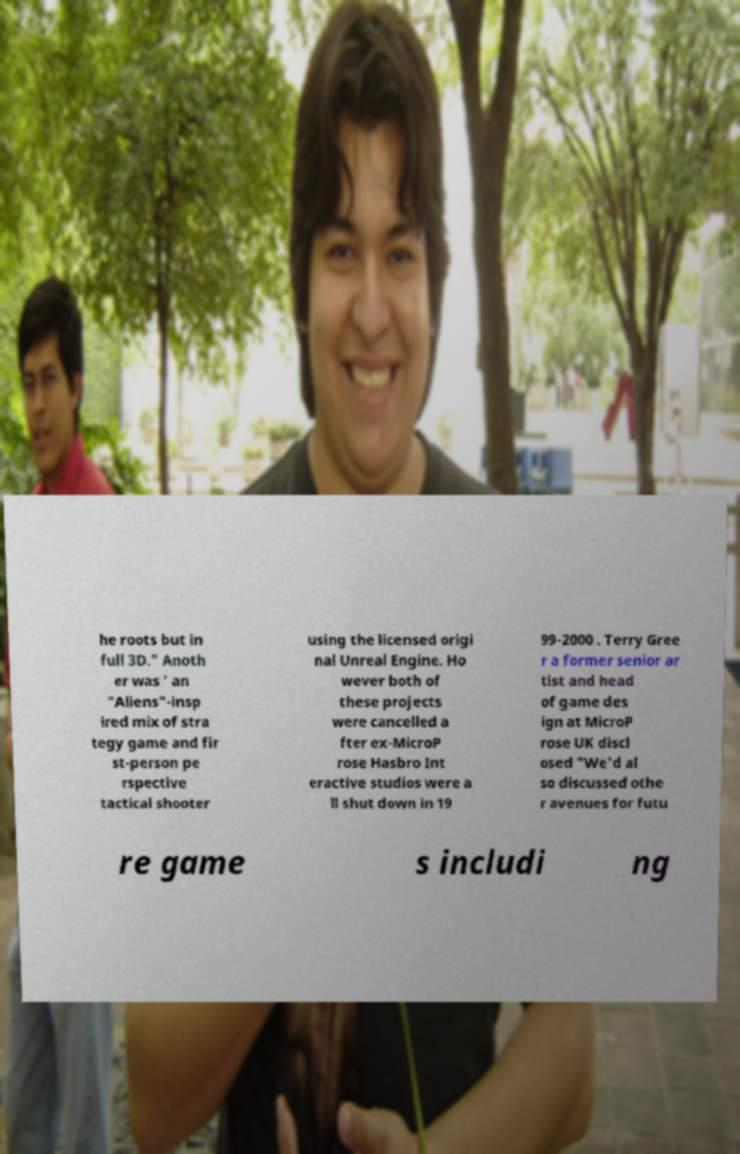I need the written content from this picture converted into text. Can you do that? he roots but in full 3D." Anoth er was ' an "Aliens"-insp ired mix of stra tegy game and fir st-person pe rspective tactical shooter using the licensed origi nal Unreal Engine. Ho wever both of these projects were cancelled a fter ex-MicroP rose Hasbro Int eractive studios were a ll shut down in 19 99-2000 . Terry Gree r a former senior ar tist and head of game des ign at MicroP rose UK discl osed "We'd al so discussed othe r avenues for futu re game s includi ng 